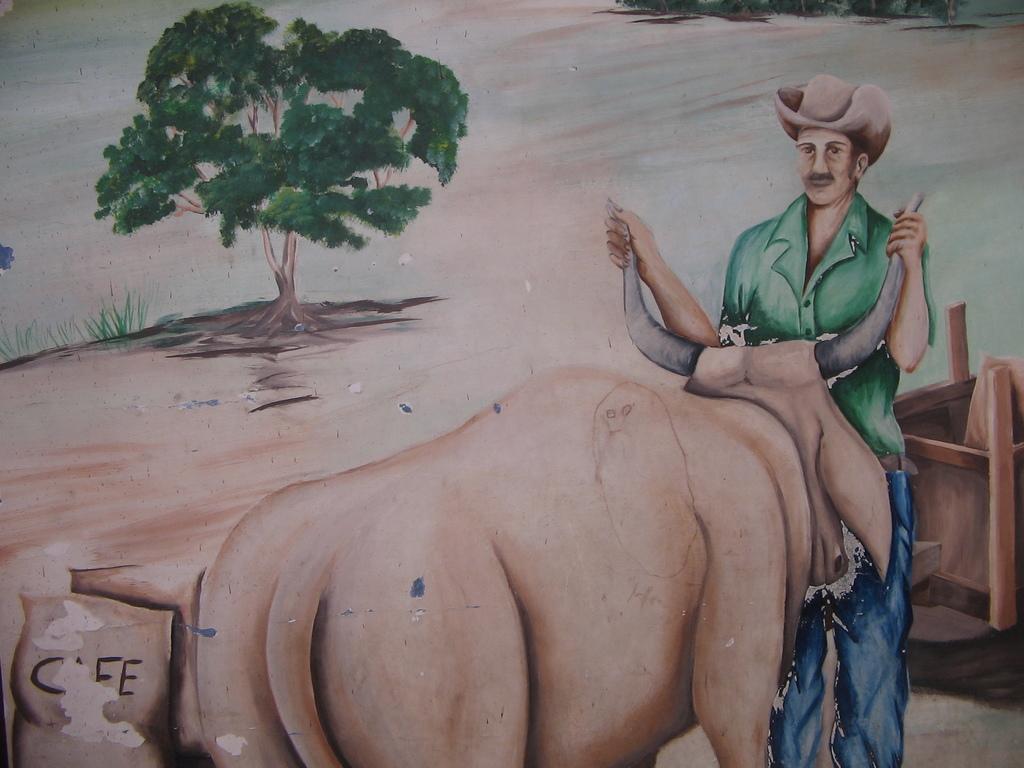What is the main subject of the image? There is an art piece in the image. Can you describe the person in the image? There is a person on the right side of the image, and he is holding bull horns with his hands. What is visible in the top left of the image? There is a tree in the top left of the image. What type of chin can be seen on the cows in the image? There are no cows present in the image, so it is not possible to determine the type of chin on any cows. What is the person sitting on in the image? The provided facts do not mention the person sitting on anything, so we cannot answer this question. 